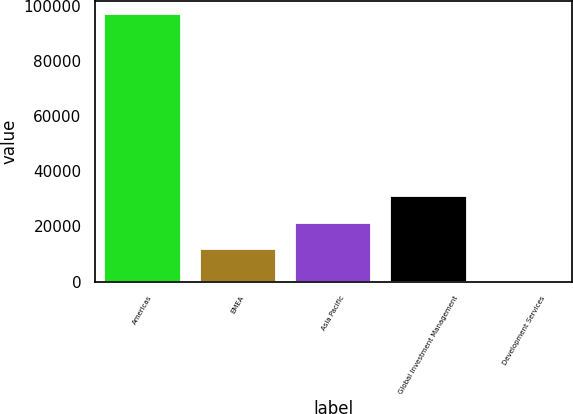Convert chart. <chart><loc_0><loc_0><loc_500><loc_500><bar_chart><fcel>Americas<fcel>EMEA<fcel>Asia Pacific<fcel>Global Investment Management<fcel>Development Services<nl><fcel>96785<fcel>11719<fcel>21377.8<fcel>31036.6<fcel>197<nl></chart> 